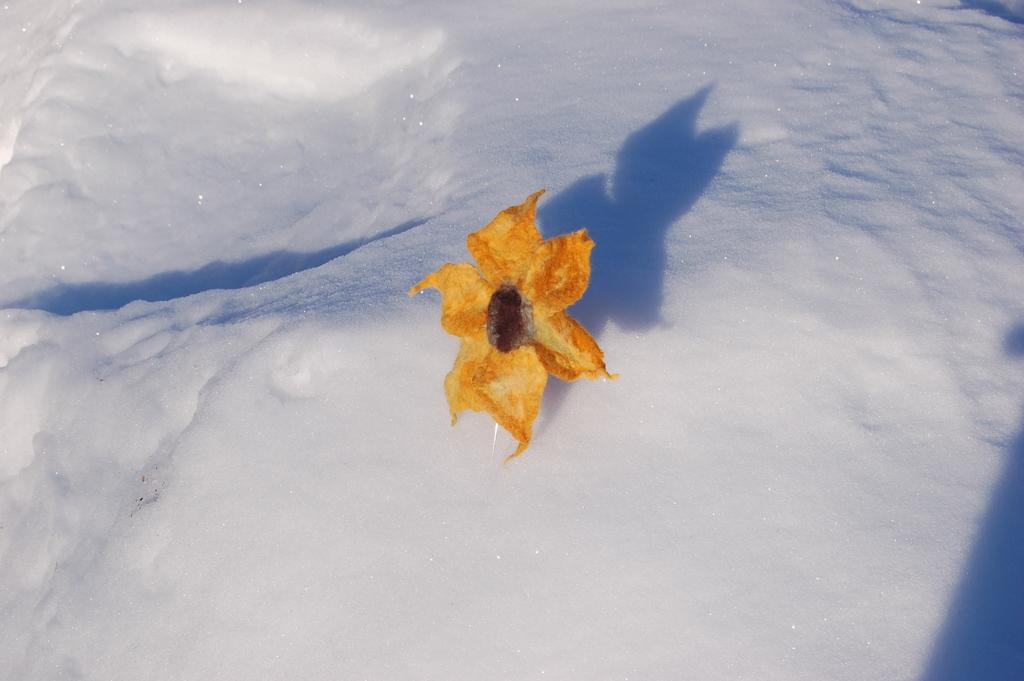How would you summarize this image in a sentence or two? In this image, we can see a flower on the snow. 